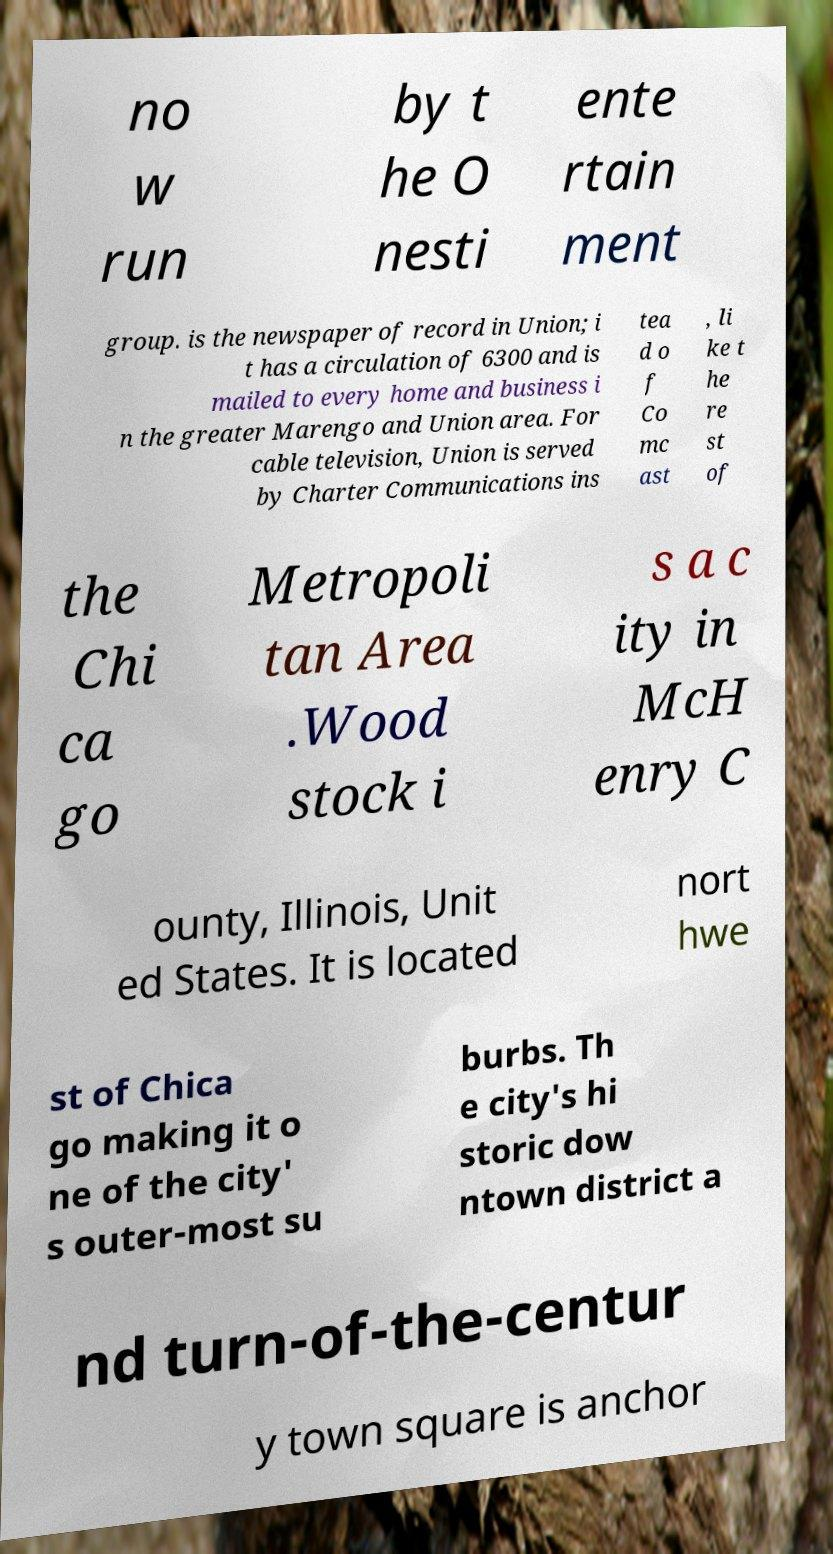Can you read and provide the text displayed in the image?This photo seems to have some interesting text. Can you extract and type it out for me? no w run by t he O nesti ente rtain ment group. is the newspaper of record in Union; i t has a circulation of 6300 and is mailed to every home and business i n the greater Marengo and Union area. For cable television, Union is served by Charter Communications ins tea d o f Co mc ast , li ke t he re st of the Chi ca go Metropoli tan Area .Wood stock i s a c ity in McH enry C ounty, Illinois, Unit ed States. It is located nort hwe st of Chica go making it o ne of the city' s outer-most su burbs. Th e city's hi storic dow ntown district a nd turn-of-the-centur y town square is anchor 